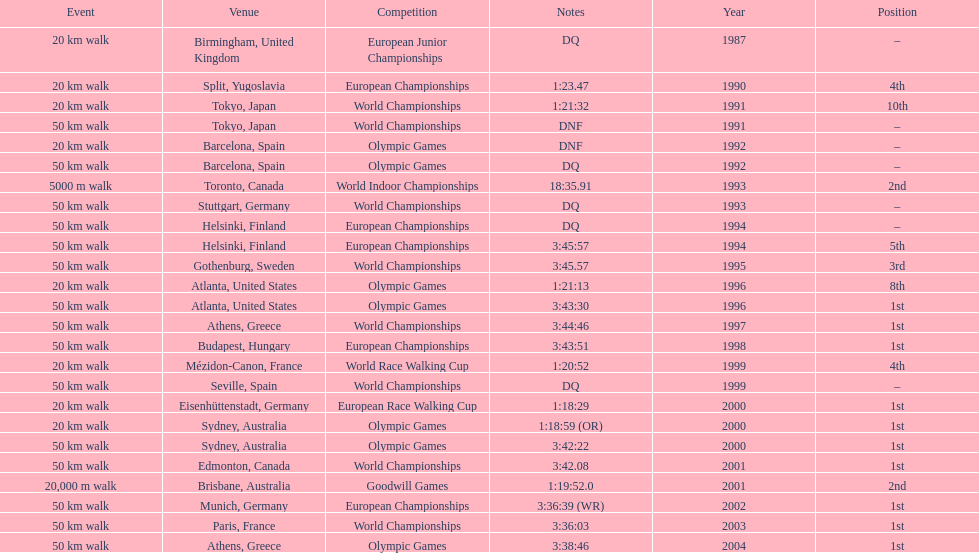Which venue is listed the most? Athens, Greece. 